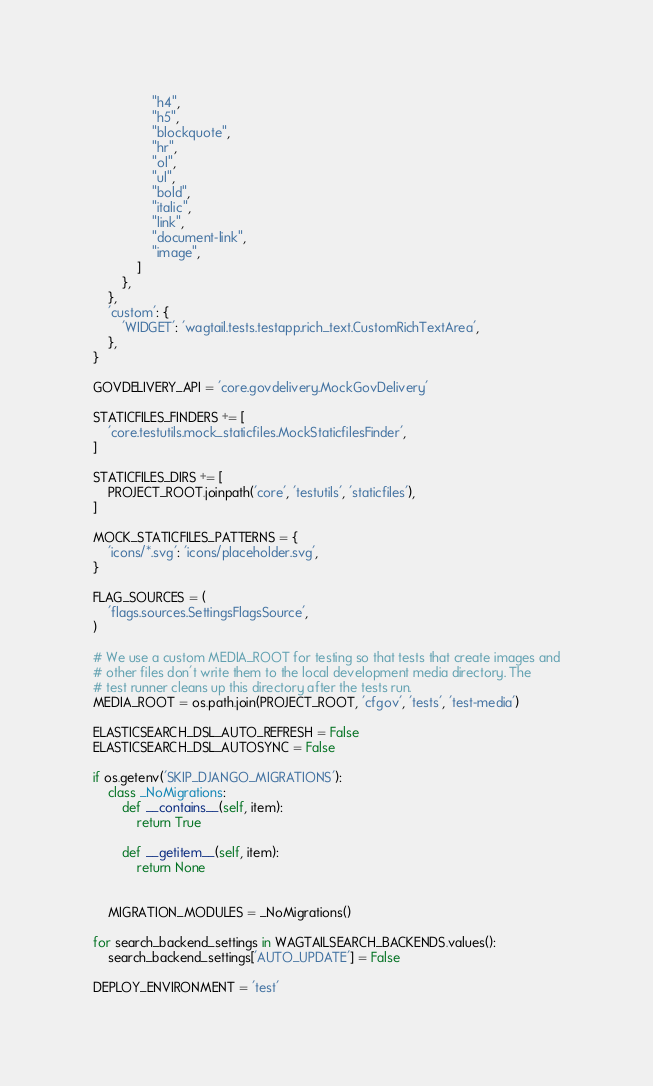Convert code to text. <code><loc_0><loc_0><loc_500><loc_500><_Python_>                "h4",
                "h5",
                "blockquote",
                "hr",
                "ol",
                "ul",
                "bold",
                "italic",
                "link",
                "document-link",
                "image",
            ]
        },
    },
    'custom': {
        'WIDGET': 'wagtail.tests.testapp.rich_text.CustomRichTextArea',
    },
}

GOVDELIVERY_API = 'core.govdelivery.MockGovDelivery'

STATICFILES_FINDERS += [
    'core.testutils.mock_staticfiles.MockStaticfilesFinder',
]

STATICFILES_DIRS += [
    PROJECT_ROOT.joinpath('core', 'testutils', 'staticfiles'),
]

MOCK_STATICFILES_PATTERNS = {
    'icons/*.svg': 'icons/placeholder.svg',
}

FLAG_SOURCES = (
    'flags.sources.SettingsFlagsSource',
)

# We use a custom MEDIA_ROOT for testing so that tests that create images and
# other files don't write them to the local development media directory. The
# test runner cleans up this directory after the tests run.
MEDIA_ROOT = os.path.join(PROJECT_ROOT, 'cfgov', 'tests', 'test-media')

ELASTICSEARCH_DSL_AUTO_REFRESH = False
ELASTICSEARCH_DSL_AUTOSYNC = False

if os.getenv('SKIP_DJANGO_MIGRATIONS'):
    class _NoMigrations:
        def __contains__(self, item):
            return True

        def __getitem__(self, item):
            return None


    MIGRATION_MODULES = _NoMigrations()

for search_backend_settings in WAGTAILSEARCH_BACKENDS.values():
    search_backend_settings['AUTO_UPDATE'] = False

DEPLOY_ENVIRONMENT = 'test'
</code> 